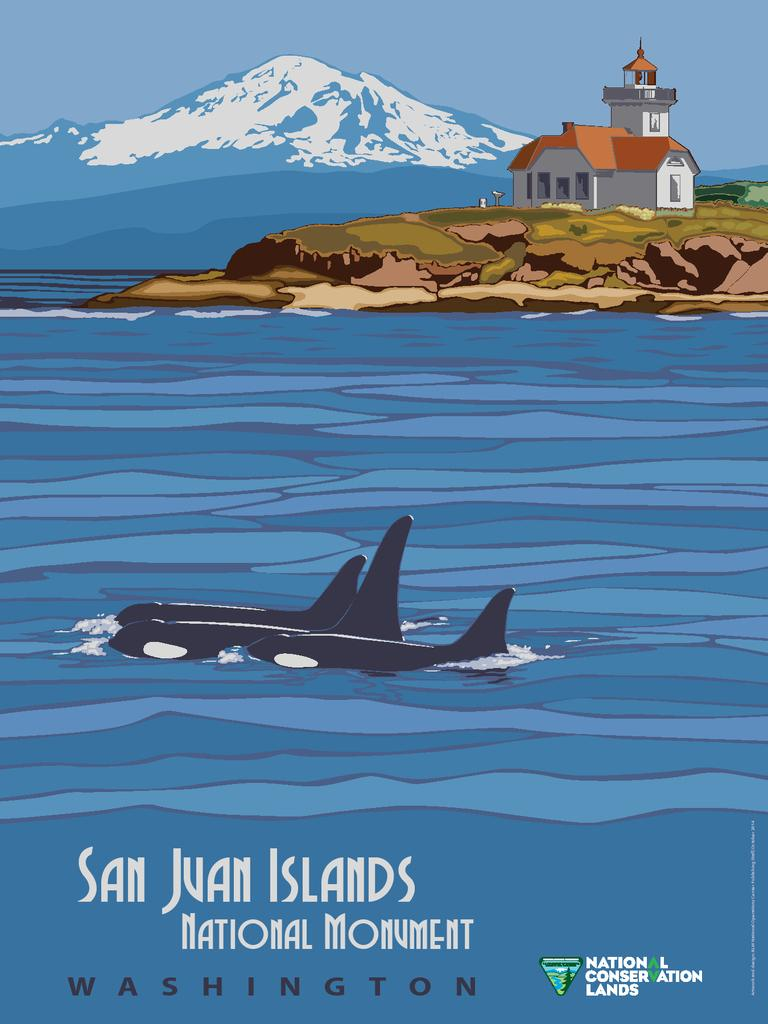<image>
Write a terse but informative summary of the picture. two whales in the water with the words San Juan Islands below them 